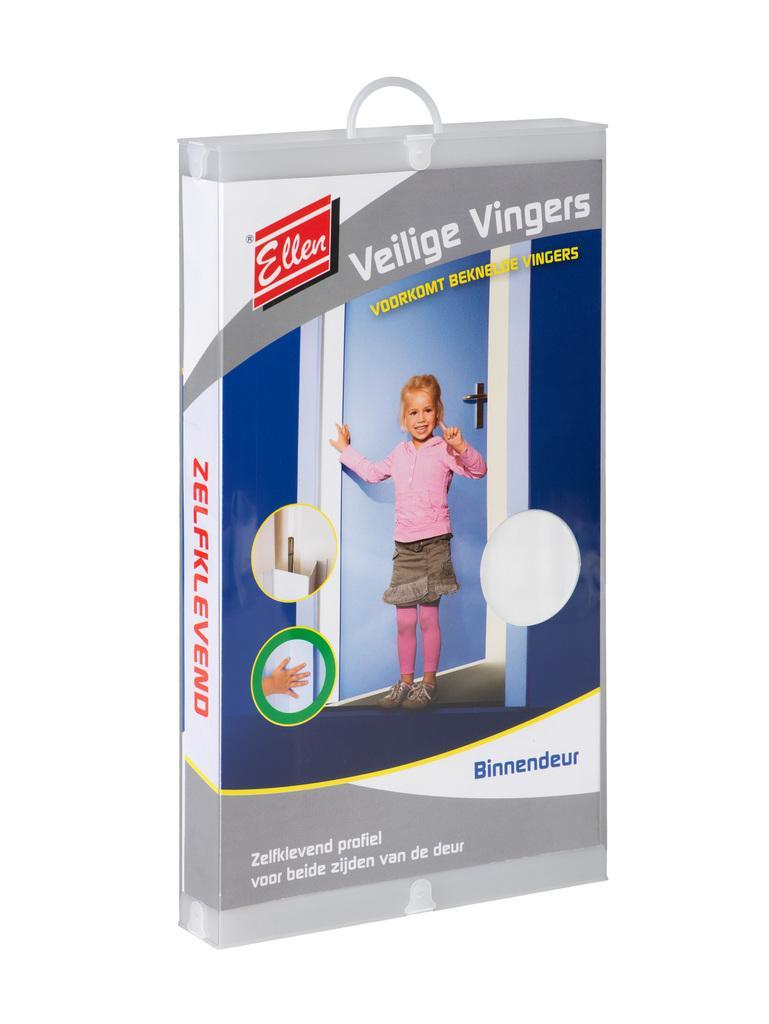Can you describe this image briefly? In the center of the image we can see a bag. 